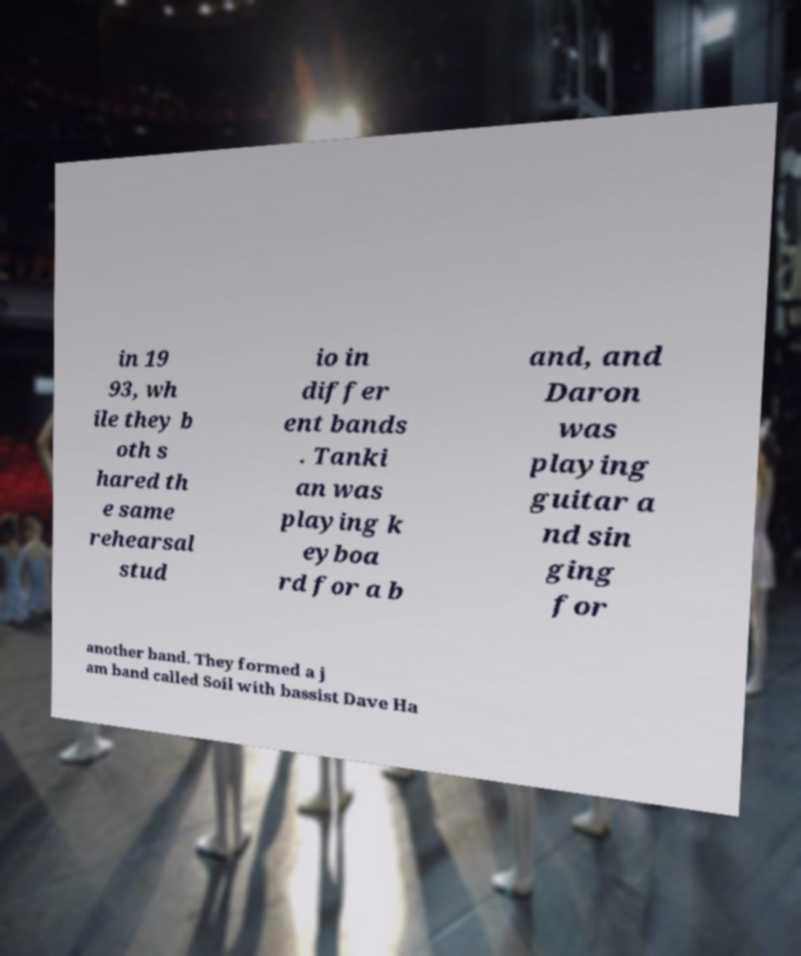Could you extract and type out the text from this image? in 19 93, wh ile they b oth s hared th e same rehearsal stud io in differ ent bands . Tanki an was playing k eyboa rd for a b and, and Daron was playing guitar a nd sin ging for another band. They formed a j am band called Soil with bassist Dave Ha 